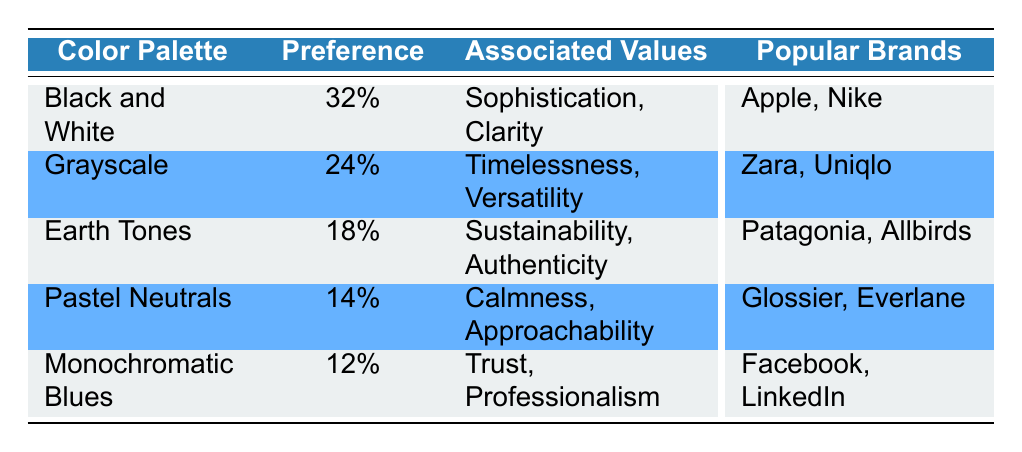What is the color palette with the highest preference percentage? The highest preference percentage in the table is 32%, corresponding to the color palette "Black and White."
Answer: Black and White Which brand is associated with the Earth Tones palette? The brand associated with the Earth Tones palette in the table is Patagonia and Allbirds.
Answer: Patagonia, Allbirds Is the preference percentage for Monochromatic Blues greater than 10%? The preference percentage for Monochromatic Blues is 12%, which is greater than 10%. Hence, the statement is true.
Answer: Yes What is the average preference percentage of the past two color palettes listed? The last two color palettes are Pastel Neutrals (14%) and Monochromatic Blues (12%). Adding them gives 14 + 12 = 26%. To find the average, divide by 2: 26% / 2 = 13%.
Answer: 13% Which color palette has the associated value of "Calmness, Approachability"? The table states that Pastel Neutrals is associated with "Calmness, Approachability."
Answer: Pastel Neutrals Are there any brands associated with the Grayscale palette? Yes, the table lists Zara and Uniqlo as the brands associated with the Grayscale palette. Therefore, the statement is true.
Answer: Yes What percentage difference is there between the Black and White palette and the Grayscale palette? The preference percentage for Black and White is 32%, and for Grayscale, it is 24%. The difference is 32% - 24% = 8%.
Answer: 8% Which color palette has the least preference percentage and what brands are associated with it? The color palette with the least preference percentage is Monochromatic Blues at 12%, associated with Facebook and LinkedIn.
Answer: Monochromatic Blues; Facebook, LinkedIn What two brand values are associated with the Grayscale color palette? The Grayscale color palette is associated with Timelessness and Versatility as listed in the table.
Answer: Timelessness, Versatility 